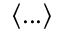Convert formula to latex. <formula><loc_0><loc_0><loc_500><loc_500>\langle \dots \rangle</formula> 